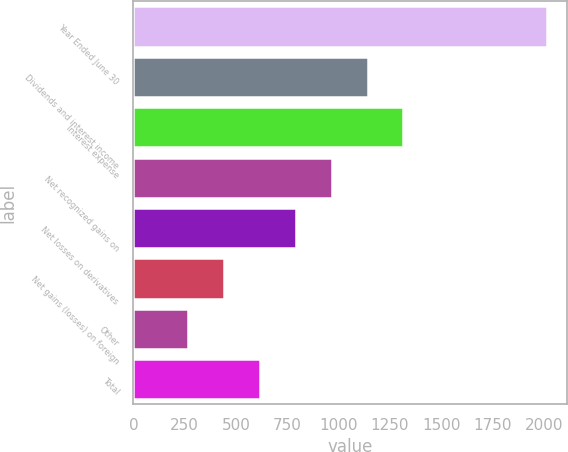<chart> <loc_0><loc_0><loc_500><loc_500><bar_chart><fcel>Year Ended June 30<fcel>Dividends and interest income<fcel>Interest expense<fcel>Net recognized gains on<fcel>Net losses on derivatives<fcel>Net gains (losses) on foreign<fcel>Other<fcel>Total<nl><fcel>2015<fcel>1141<fcel>1315.8<fcel>966.2<fcel>791.4<fcel>441.8<fcel>267<fcel>616.6<nl></chart> 